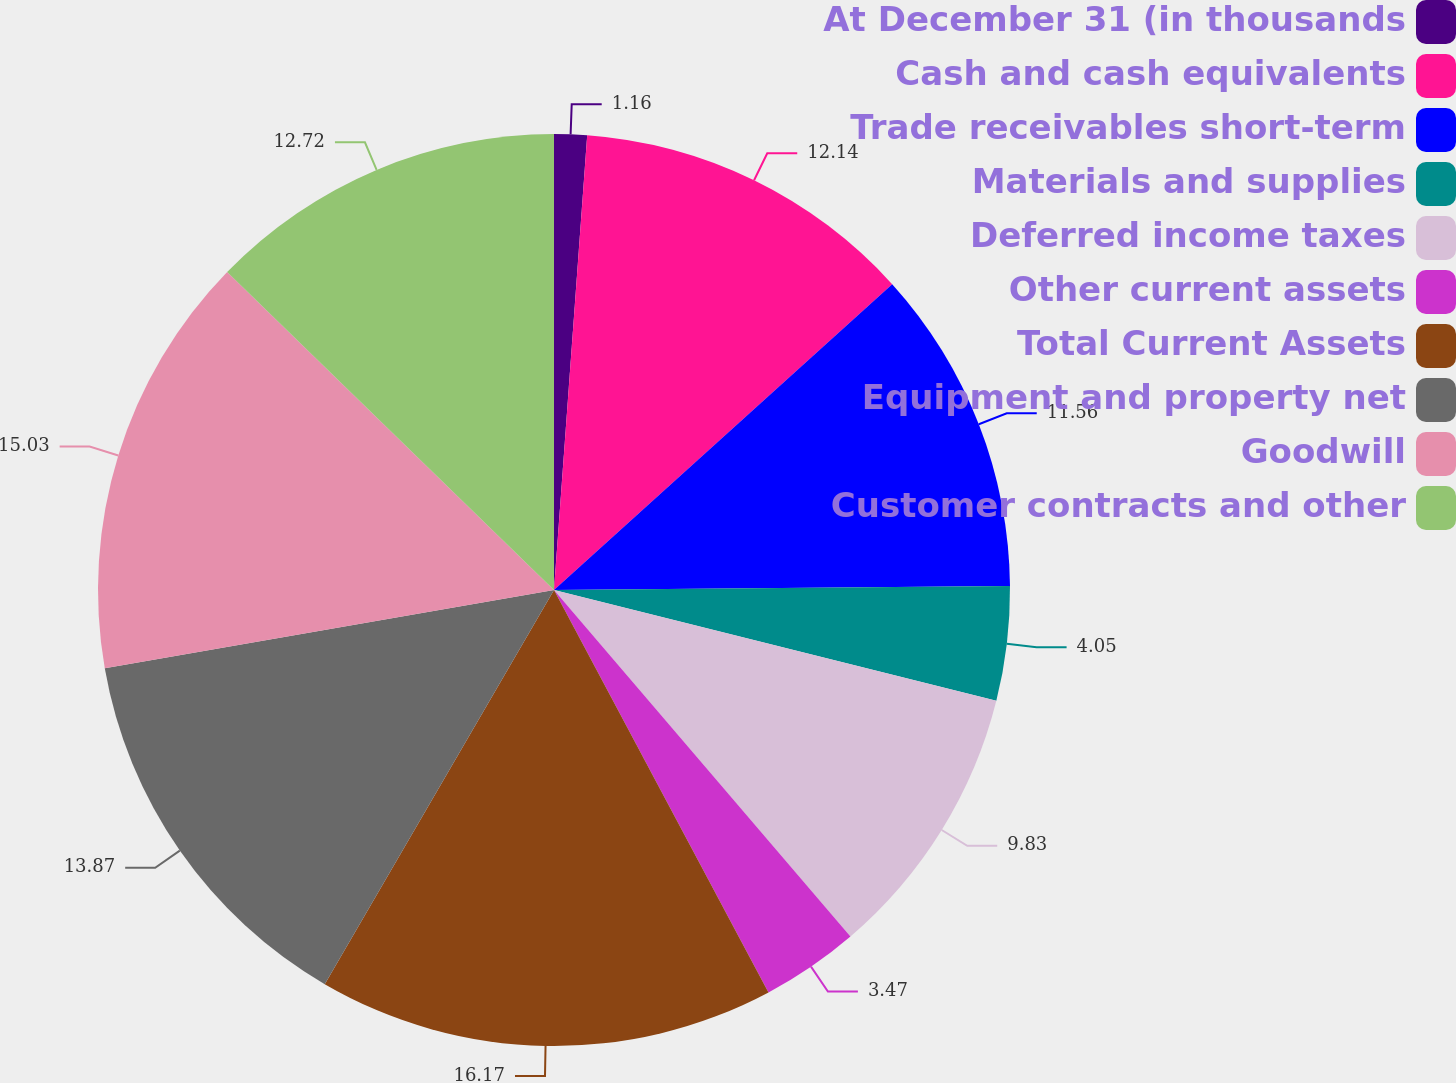Convert chart to OTSL. <chart><loc_0><loc_0><loc_500><loc_500><pie_chart><fcel>At December 31 (in thousands<fcel>Cash and cash equivalents<fcel>Trade receivables short-term<fcel>Materials and supplies<fcel>Deferred income taxes<fcel>Other current assets<fcel>Total Current Assets<fcel>Equipment and property net<fcel>Goodwill<fcel>Customer contracts and other<nl><fcel>1.16%<fcel>12.14%<fcel>11.56%<fcel>4.05%<fcel>9.83%<fcel>3.47%<fcel>16.18%<fcel>13.87%<fcel>15.03%<fcel>12.72%<nl></chart> 